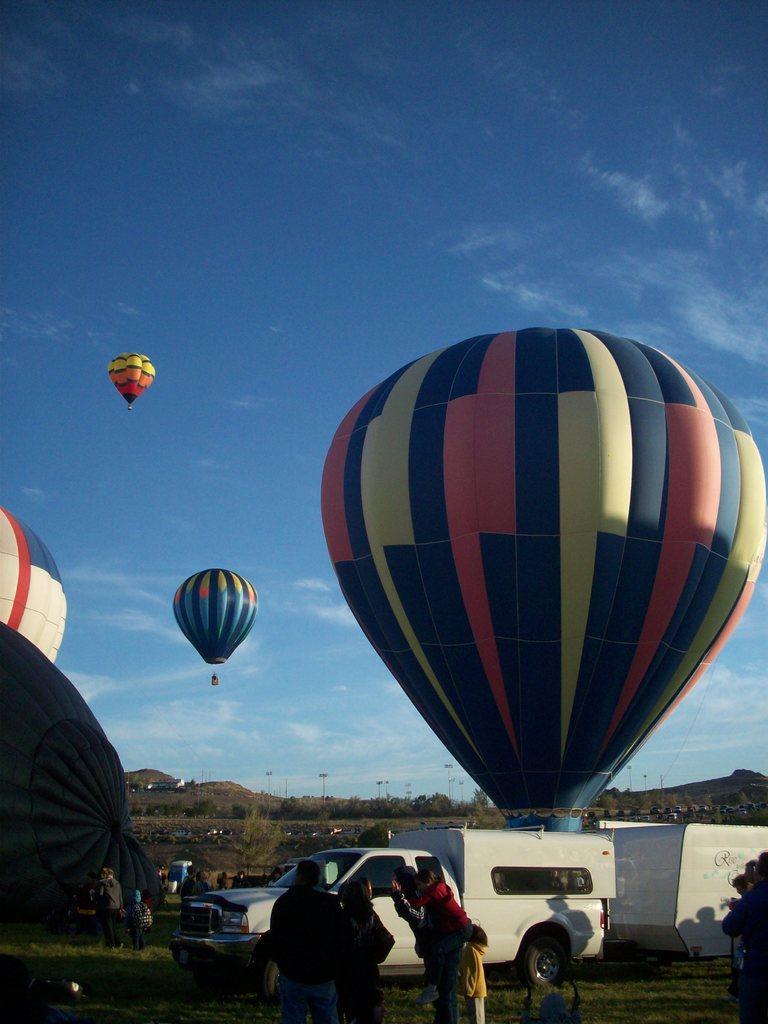How would you summarize this image in a sentence or two? In this image in front there are people. Behind them there is a vehicle. There are hot air balloons. At the bottom of the image there is grass on the surface. In the background of the image there are trees, mountains, lights and sky. 